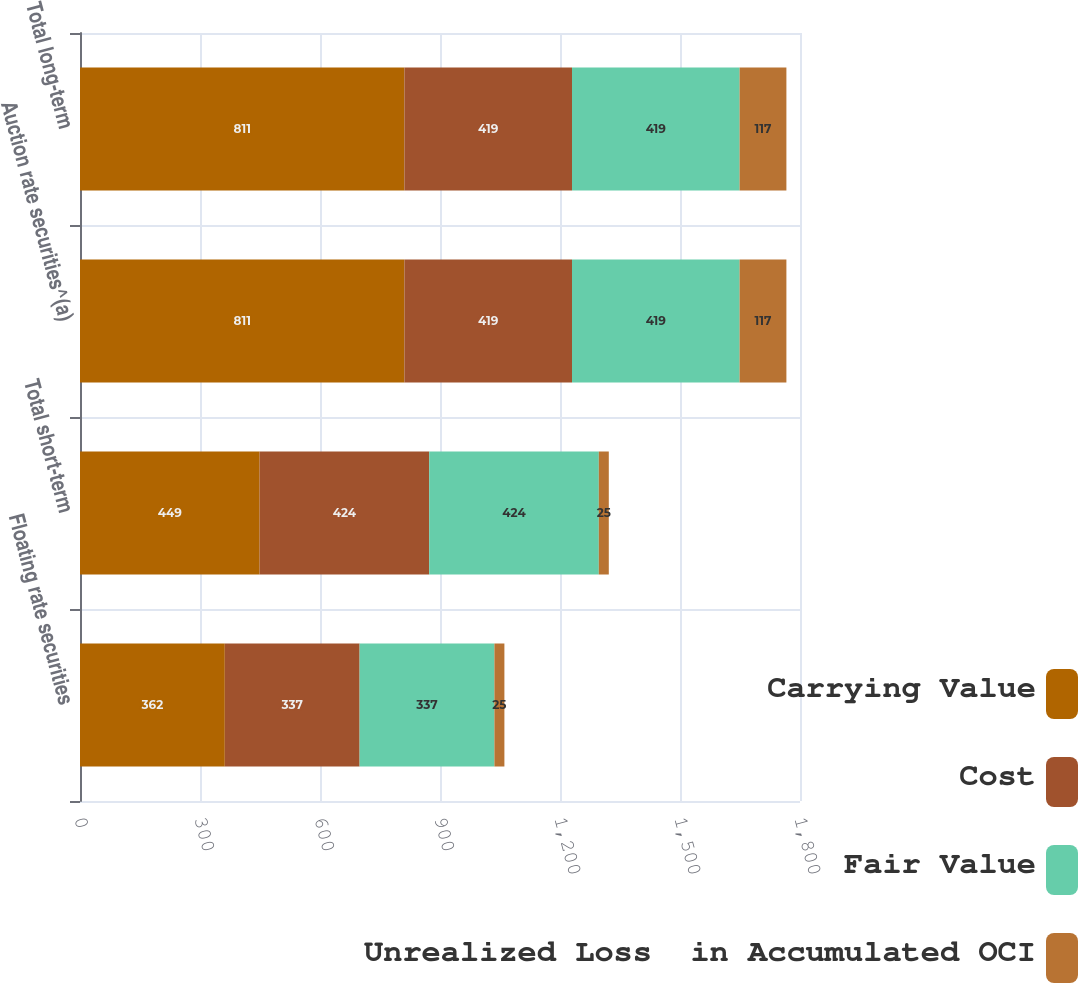Convert chart. <chart><loc_0><loc_0><loc_500><loc_500><stacked_bar_chart><ecel><fcel>Floating rate securities<fcel>Total short-term<fcel>Auction rate securities^(a)<fcel>Total long-term<nl><fcel>Carrying Value<fcel>362<fcel>449<fcel>811<fcel>811<nl><fcel>Cost<fcel>337<fcel>424<fcel>419<fcel>419<nl><fcel>Fair Value<fcel>337<fcel>424<fcel>419<fcel>419<nl><fcel>Unrealized Loss  in Accumulated OCI<fcel>25<fcel>25<fcel>117<fcel>117<nl></chart> 